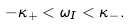<formula> <loc_0><loc_0><loc_500><loc_500>- \kappa _ { + } < \omega _ { I } < \kappa _ { - } .</formula> 